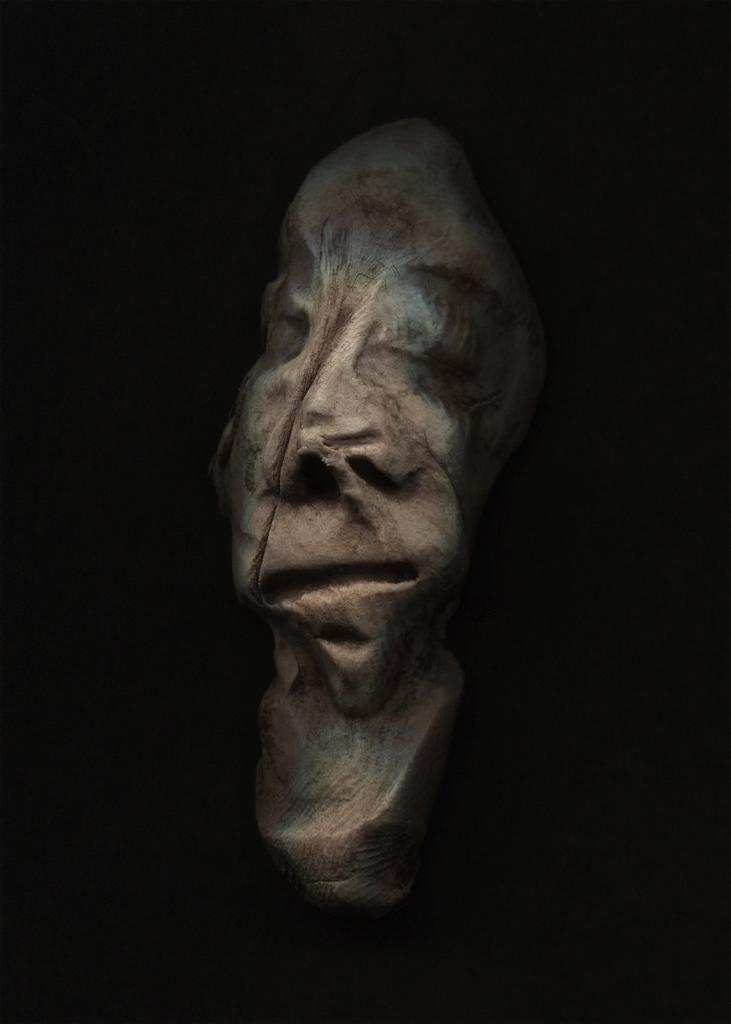What is the main subject of the image? There is a person depicted in the image. What color is the background of the image? The background of the image is black. What type of soda is the person holding in the image? There is no soda present in the image; only a person and a black background are visible. 